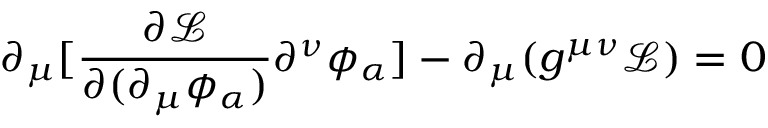Convert formula to latex. <formula><loc_0><loc_0><loc_500><loc_500>\partial _ { \mu } [ { \frac { \partial { \mathcal { L } } } { \partial ( \partial _ { \mu } \phi _ { \alpha } ) } } \partial ^ { \nu } \phi _ { \alpha } ] - \partial _ { \mu } ( g ^ { \mu \nu } { \mathcal { L } } ) = 0</formula> 